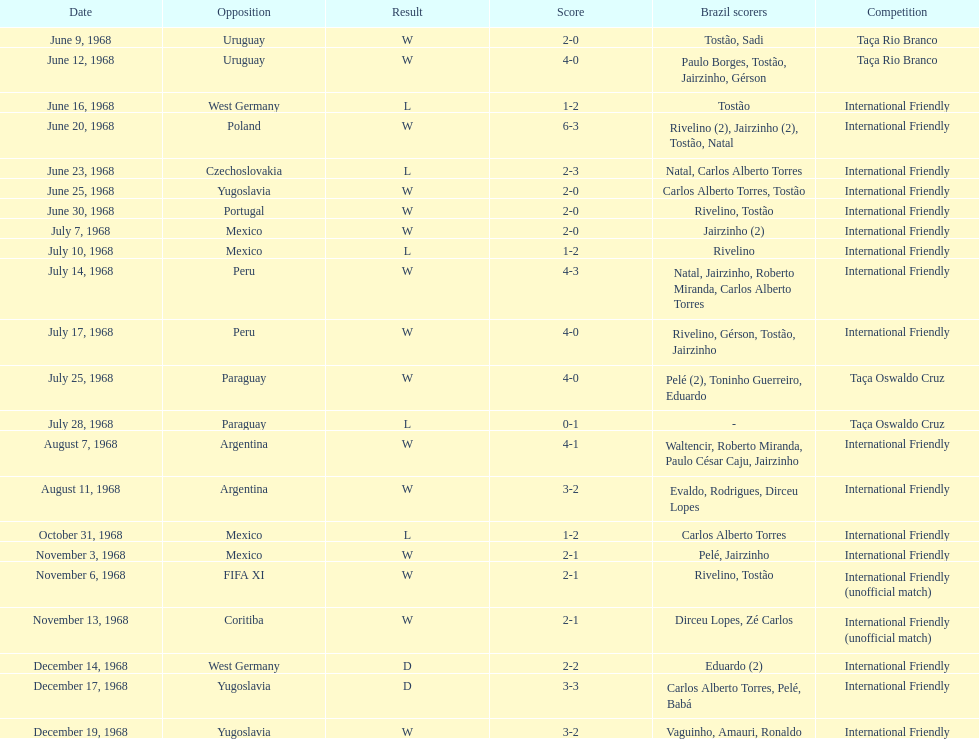How many contests are triumphs? 15. 